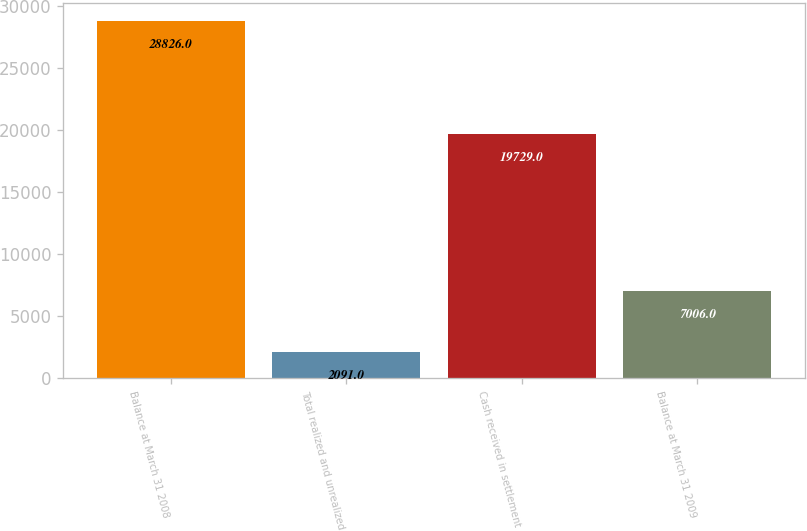Convert chart. <chart><loc_0><loc_0><loc_500><loc_500><bar_chart><fcel>Balance at March 31 2008<fcel>Total realized and unrealized<fcel>Cash received in settlement<fcel>Balance at March 31 2009<nl><fcel>28826<fcel>2091<fcel>19729<fcel>7006<nl></chart> 